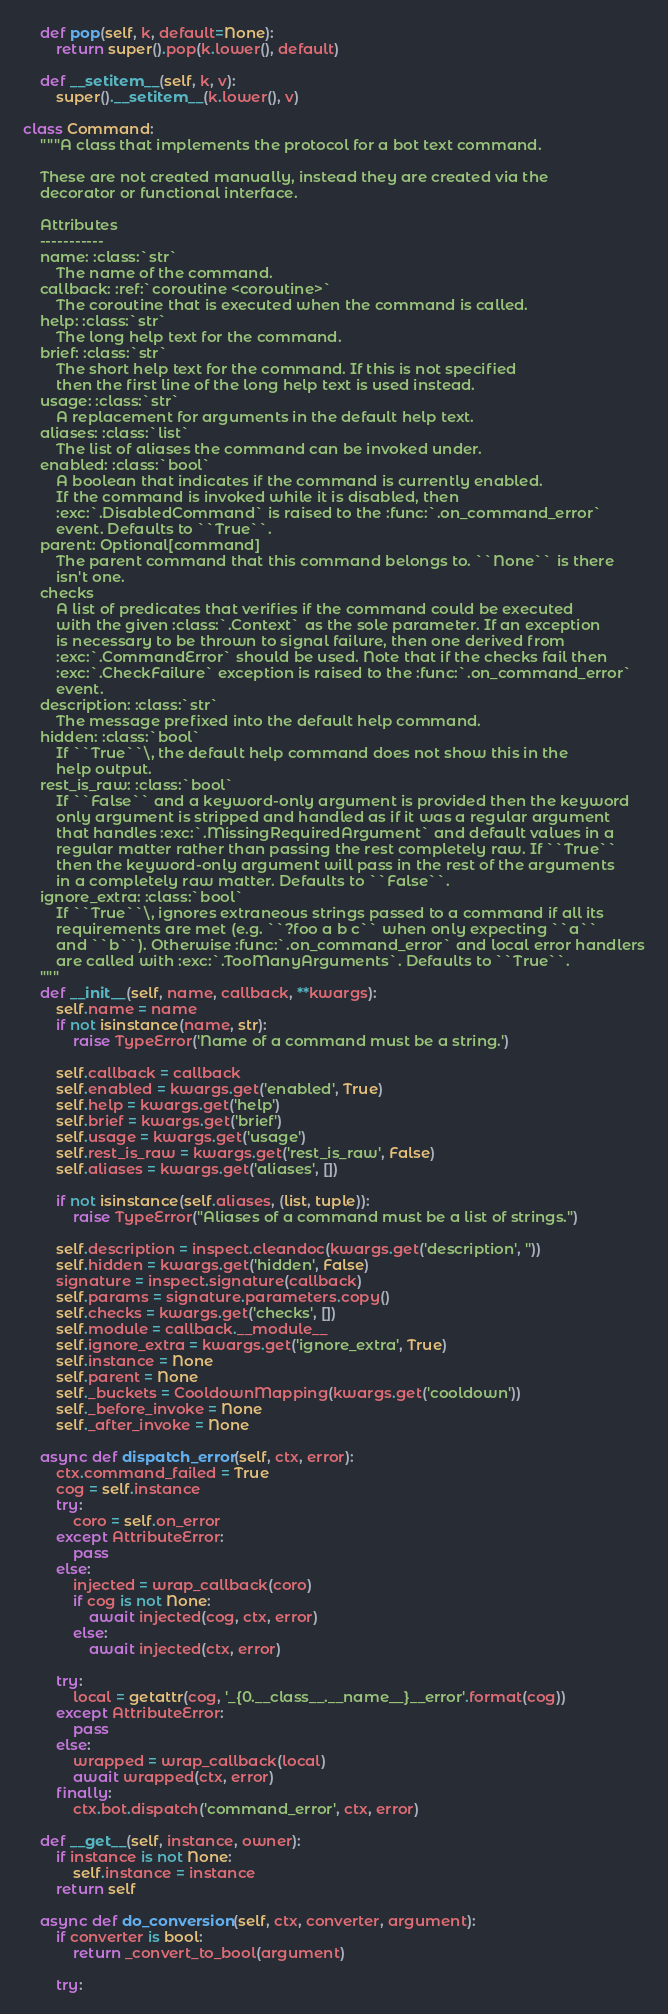<code> <loc_0><loc_0><loc_500><loc_500><_Python_>
    def pop(self, k, default=None):
        return super().pop(k.lower(), default)

    def __setitem__(self, k, v):
        super().__setitem__(k.lower(), v)

class Command:
    """A class that implements the protocol for a bot text command.

    These are not created manually, instead they are created via the
    decorator or functional interface.

    Attributes
    -----------
    name: :class:`str`
        The name of the command.
    callback: :ref:`coroutine <coroutine>`
        The coroutine that is executed when the command is called.
    help: :class:`str`
        The long help text for the command.
    brief: :class:`str`
        The short help text for the command. If this is not specified
        then the first line of the long help text is used instead.
    usage: :class:`str`
        A replacement for arguments in the default help text.
    aliases: :class:`list`
        The list of aliases the command can be invoked under.
    enabled: :class:`bool`
        A boolean that indicates if the command is currently enabled.
        If the command is invoked while it is disabled, then
        :exc:`.DisabledCommand` is raised to the :func:`.on_command_error`
        event. Defaults to ``True``.
    parent: Optional[command]
        The parent command that this command belongs to. ``None`` is there
        isn't one.
    checks
        A list of predicates that verifies if the command could be executed
        with the given :class:`.Context` as the sole parameter. If an exception
        is necessary to be thrown to signal failure, then one derived from
        :exc:`.CommandError` should be used. Note that if the checks fail then
        :exc:`.CheckFailure` exception is raised to the :func:`.on_command_error`
        event.
    description: :class:`str`
        The message prefixed into the default help command.
    hidden: :class:`bool`
        If ``True``\, the default help command does not show this in the
        help output.
    rest_is_raw: :class:`bool`
        If ``False`` and a keyword-only argument is provided then the keyword
        only argument is stripped and handled as if it was a regular argument
        that handles :exc:`.MissingRequiredArgument` and default values in a
        regular matter rather than passing the rest completely raw. If ``True``
        then the keyword-only argument will pass in the rest of the arguments
        in a completely raw matter. Defaults to ``False``.
    ignore_extra: :class:`bool`
        If ``True``\, ignores extraneous strings passed to a command if all its
        requirements are met (e.g. ``?foo a b c`` when only expecting ``a``
        and ``b``). Otherwise :func:`.on_command_error` and local error handlers
        are called with :exc:`.TooManyArguments`. Defaults to ``True``.
    """
    def __init__(self, name, callback, **kwargs):
        self.name = name
        if not isinstance(name, str):
            raise TypeError('Name of a command must be a string.')

        self.callback = callback
        self.enabled = kwargs.get('enabled', True)
        self.help = kwargs.get('help')
        self.brief = kwargs.get('brief')
        self.usage = kwargs.get('usage')
        self.rest_is_raw = kwargs.get('rest_is_raw', False)
        self.aliases = kwargs.get('aliases', [])

        if not isinstance(self.aliases, (list, tuple)):
            raise TypeError("Aliases of a command must be a list of strings.")

        self.description = inspect.cleandoc(kwargs.get('description', ''))
        self.hidden = kwargs.get('hidden', False)
        signature = inspect.signature(callback)
        self.params = signature.parameters.copy()
        self.checks = kwargs.get('checks', [])
        self.module = callback.__module__
        self.ignore_extra = kwargs.get('ignore_extra', True)
        self.instance = None
        self.parent = None
        self._buckets = CooldownMapping(kwargs.get('cooldown'))
        self._before_invoke = None
        self._after_invoke = None

    async def dispatch_error(self, ctx, error):
        ctx.command_failed = True
        cog = self.instance
        try:
            coro = self.on_error
        except AttributeError:
            pass
        else:
            injected = wrap_callback(coro)
            if cog is not None:
                await injected(cog, ctx, error)
            else:
                await injected(ctx, error)

        try:
            local = getattr(cog, '_{0.__class__.__name__}__error'.format(cog))
        except AttributeError:
            pass
        else:
            wrapped = wrap_callback(local)
            await wrapped(ctx, error)
        finally:
            ctx.bot.dispatch('command_error', ctx, error)

    def __get__(self, instance, owner):
        if instance is not None:
            self.instance = instance
        return self

    async def do_conversion(self, ctx, converter, argument):
        if converter is bool:
            return _convert_to_bool(argument)

        try:</code> 